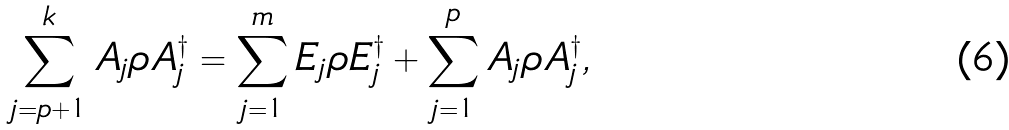<formula> <loc_0><loc_0><loc_500><loc_500>\sum _ { j = p + 1 } ^ { k } A _ { j } \rho A _ { j } ^ { \dagger } = \sum _ { j = 1 } ^ { m } E _ { j } \rho E _ { j } ^ { \dagger } + \sum _ { j = 1 } ^ { p } A _ { j } \rho A _ { j } ^ { \dagger } ,</formula> 